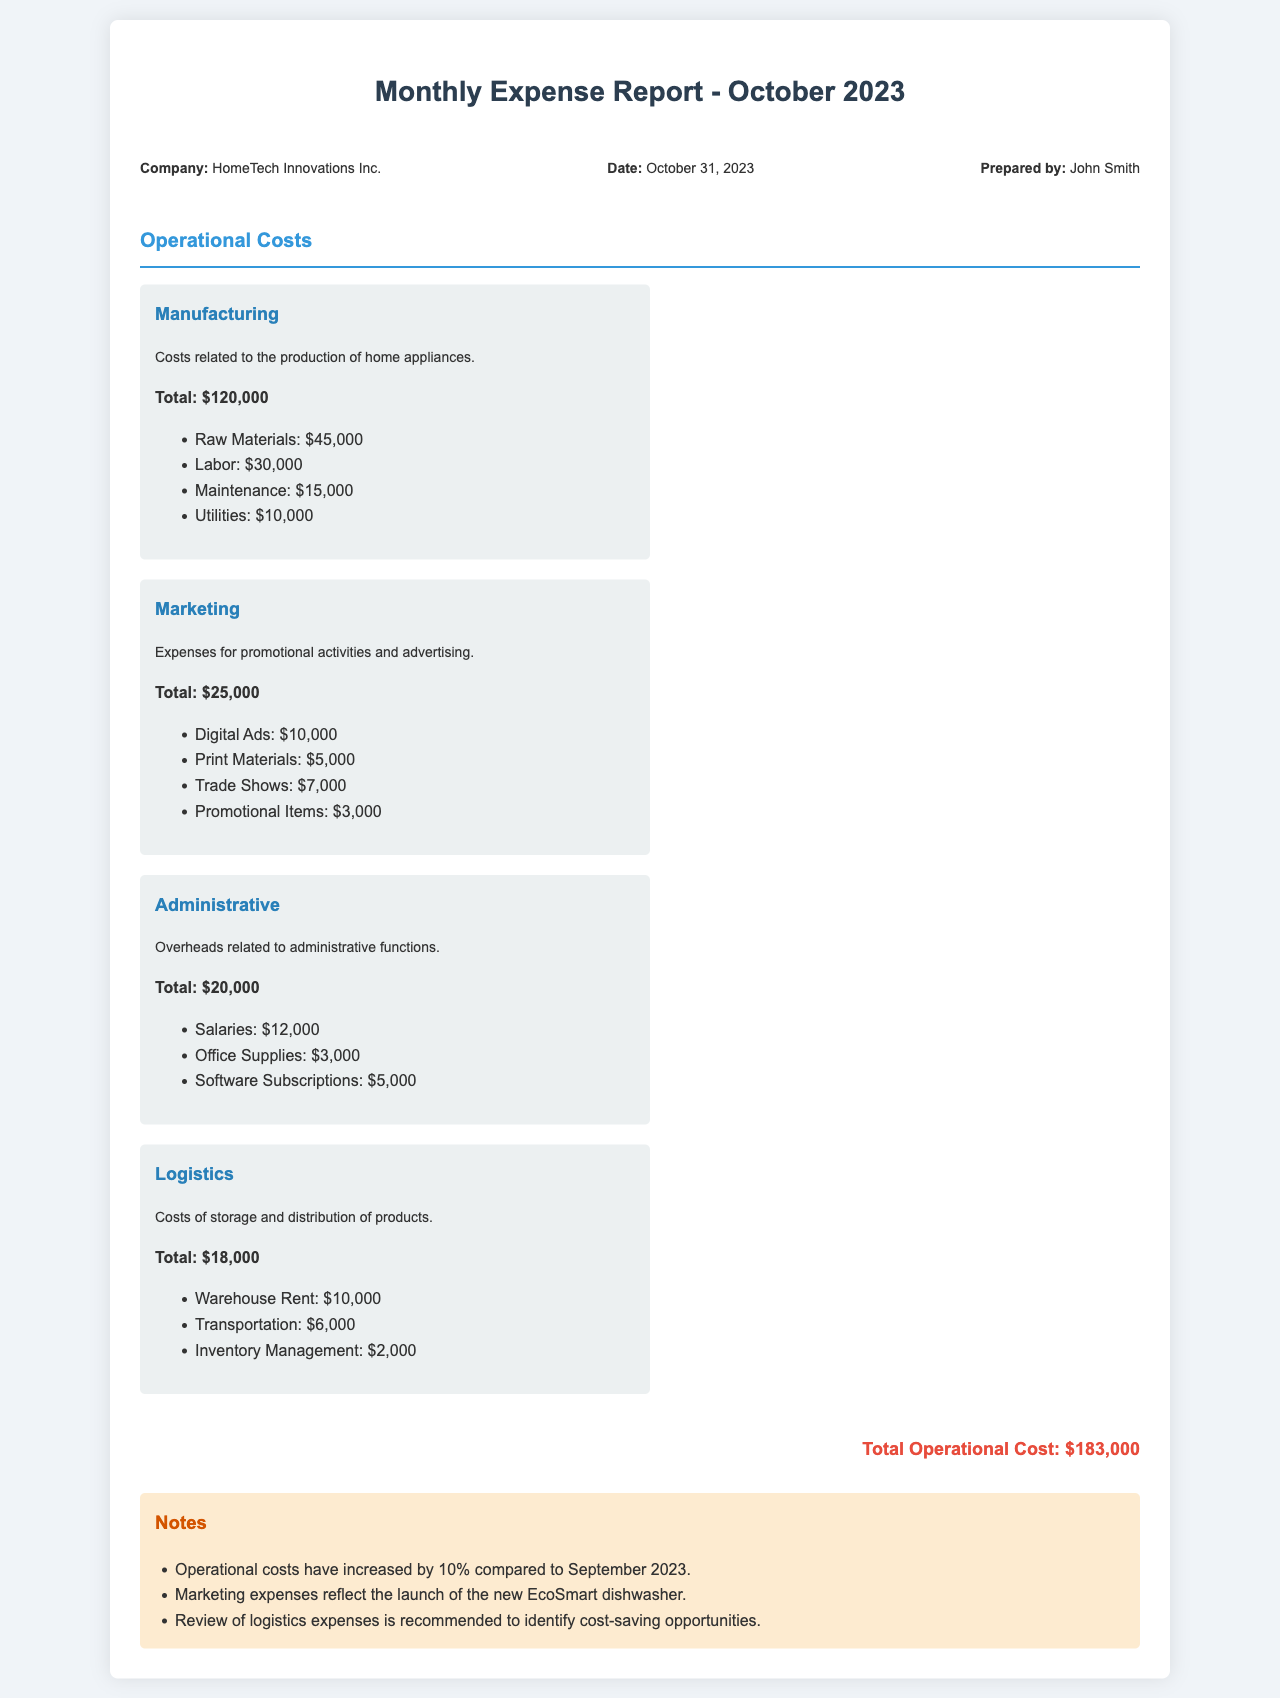What is the total operational cost? The total operational cost is explicitly stated in the document, which sums up all the individual costs outlined.
Answer: $183,000 Who prepared the report? The name of the individual responsible for preparing the report is mentioned in the header information section of the document.
Answer: John Smith What is the cost of raw materials? The document specifies the breakdown of costs associated with manufacturing, including the cost of raw materials.
Answer: $45,000 What percentage increase in operational costs is noted for October 2023 compared to September 2023? The notes section mentions a specific percentage increase in operational costs compared to the previous month.
Answer: 10% How much was spent on digital ads? The marketing costs are broken down, and the cost allocated for digital ads is clearly stated in the document.
Answer: $10,000 What is the total amount spent on logistics? The logistics section provides a total that summarizes all associated costs for that category.
Answer: $18,000 What marketing expense reflects the launch of a new product? The notes section highlights an expense type that corresponds to a specific marketing initiative.
Answer: EcoSmart dishwasher What are the administrative overheads related to? The document includes a brief description concerning the nature of administrative overheads listed under the administrative costs section.
Answer: Administrative functions What is the total cost for maintenance in manufacturing? The breakdown of costs in the manufacturing category includes a specific line item for maintenance, which is provided in the document.
Answer: $15,000 